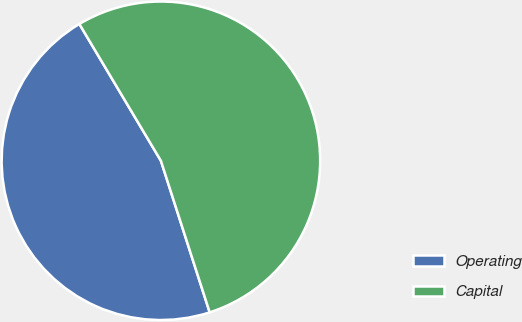<chart> <loc_0><loc_0><loc_500><loc_500><pie_chart><fcel>Operating<fcel>Capital<nl><fcel>46.4%<fcel>53.6%<nl></chart> 